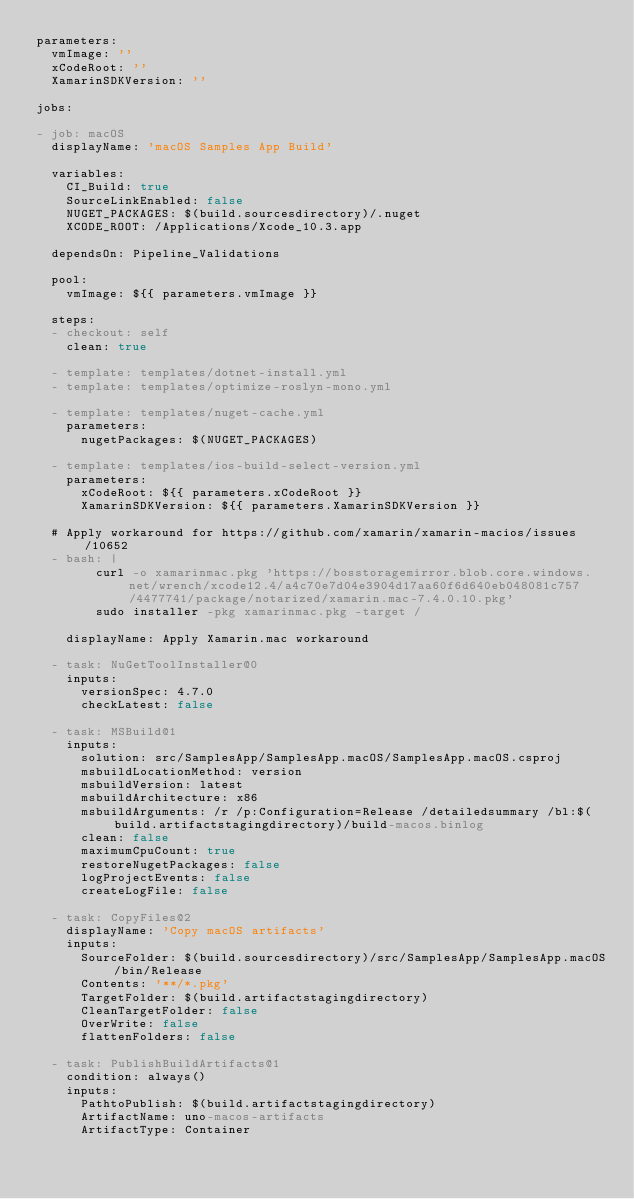<code> <loc_0><loc_0><loc_500><loc_500><_YAML_>parameters:
  vmImage: ''
  xCodeRoot: ''
  XamarinSDKVersion: ''

jobs:

- job: macOS
  displayName: 'macOS Samples App Build'

  variables:
    CI_Build: true
    SourceLinkEnabled: false
    NUGET_PACKAGES: $(build.sourcesdirectory)/.nuget
    XCODE_ROOT: /Applications/Xcode_10.3.app
    
  dependsOn: Pipeline_Validations

  pool:
    vmImage: ${{ parameters.vmImage }}

  steps:
  - checkout: self
    clean: true
    
  - template: templates/dotnet-install.yml
  - template: templates/optimize-roslyn-mono.yml

  - template: templates/nuget-cache.yml
    parameters:
      nugetPackages: $(NUGET_PACKAGES)

  - template: templates/ios-build-select-version.yml
    parameters:
      xCodeRoot: ${{ parameters.xCodeRoot }}
      XamarinSDKVersion: ${{ parameters.XamarinSDKVersion }}

  # Apply workaround for https://github.com/xamarin/xamarin-macios/issues/10652
  - bash: |
        curl -o xamarinmac.pkg 'https://bosstoragemirror.blob.core.windows.net/wrench/xcode12.4/a4c70e7d04e3904d17aa60f6d640eb048081c757/4477741/package/notarized/xamarin.mac-7.4.0.10.pkg'
        sudo installer -pkg xamarinmac.pkg -target /

    displayName: Apply Xamarin.mac workaround

  - task: NuGetToolInstaller@0
    inputs:
      versionSpec: 4.7.0
      checkLatest: false

  - task: MSBuild@1
    inputs:
      solution: src/SamplesApp/SamplesApp.macOS/SamplesApp.macOS.csproj
      msbuildLocationMethod: version
      msbuildVersion: latest
      msbuildArchitecture: x86
      msbuildArguments: /r /p:Configuration=Release /detailedsummary /bl:$(build.artifactstagingdirectory)/build-macos.binlog
      clean: false
      maximumCpuCount: true
      restoreNugetPackages: false
      logProjectEvents: false
      createLogFile: false

  - task: CopyFiles@2
    displayName: 'Copy macOS artifacts'
    inputs:
      SourceFolder: $(build.sourcesdirectory)/src/SamplesApp/SamplesApp.macOS/bin/Release
      Contents: '**/*.pkg'
      TargetFolder: $(build.artifactstagingdirectory)
      CleanTargetFolder: false
      OverWrite: false
      flattenFolders: false

  - task: PublishBuildArtifacts@1
    condition: always()
    inputs:
      PathtoPublish: $(build.artifactstagingdirectory)
      ArtifactName: uno-macos-artifacts
      ArtifactType: Container
</code> 